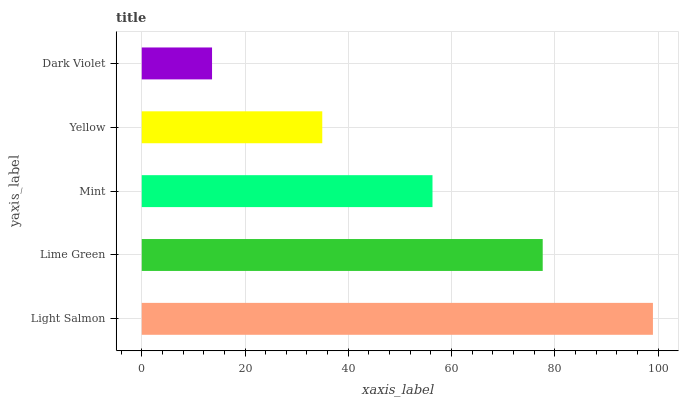Is Dark Violet the minimum?
Answer yes or no. Yes. Is Light Salmon the maximum?
Answer yes or no. Yes. Is Lime Green the minimum?
Answer yes or no. No. Is Lime Green the maximum?
Answer yes or no. No. Is Light Salmon greater than Lime Green?
Answer yes or no. Yes. Is Lime Green less than Light Salmon?
Answer yes or no. Yes. Is Lime Green greater than Light Salmon?
Answer yes or no. No. Is Light Salmon less than Lime Green?
Answer yes or no. No. Is Mint the high median?
Answer yes or no. Yes. Is Mint the low median?
Answer yes or no. Yes. Is Dark Violet the high median?
Answer yes or no. No. Is Light Salmon the low median?
Answer yes or no. No. 